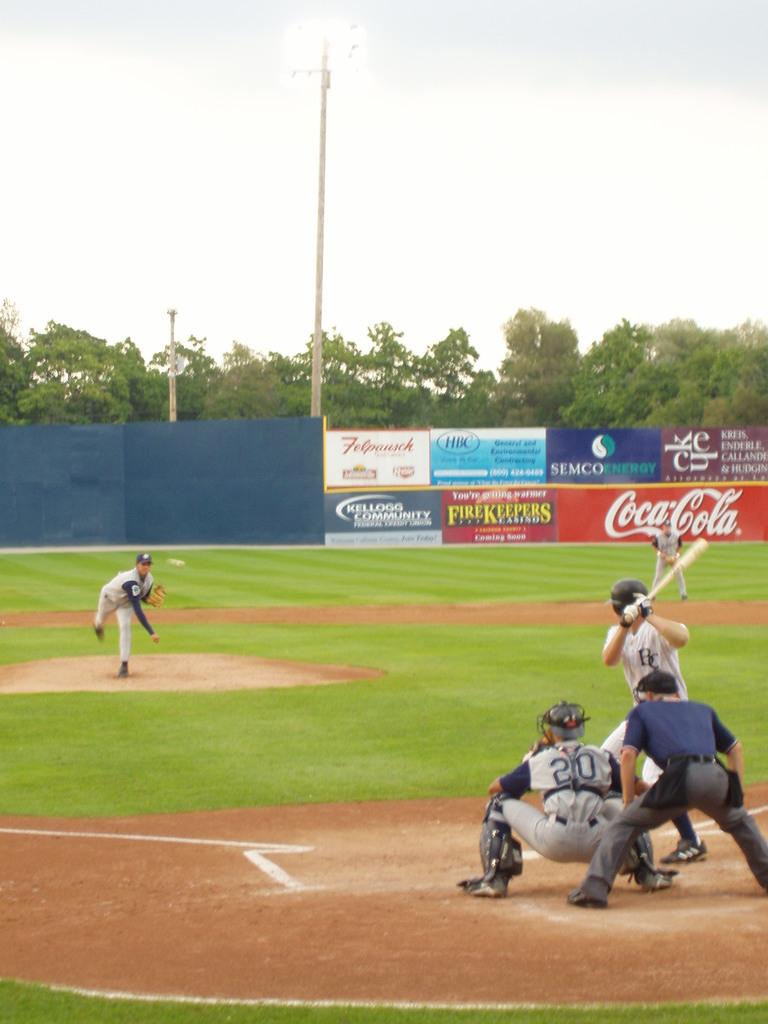What soda product is a sponsor for the stadium?
Ensure brevity in your answer.  Coca cola. What is then name of the energy company's sponsored banner?
Provide a short and direct response. Semco. 